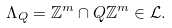<formula> <loc_0><loc_0><loc_500><loc_500>\Lambda _ { Q } = \mathbb { Z } ^ { m } \cap Q \mathbb { Z } ^ { m } \in \mathcal { L } .</formula> 